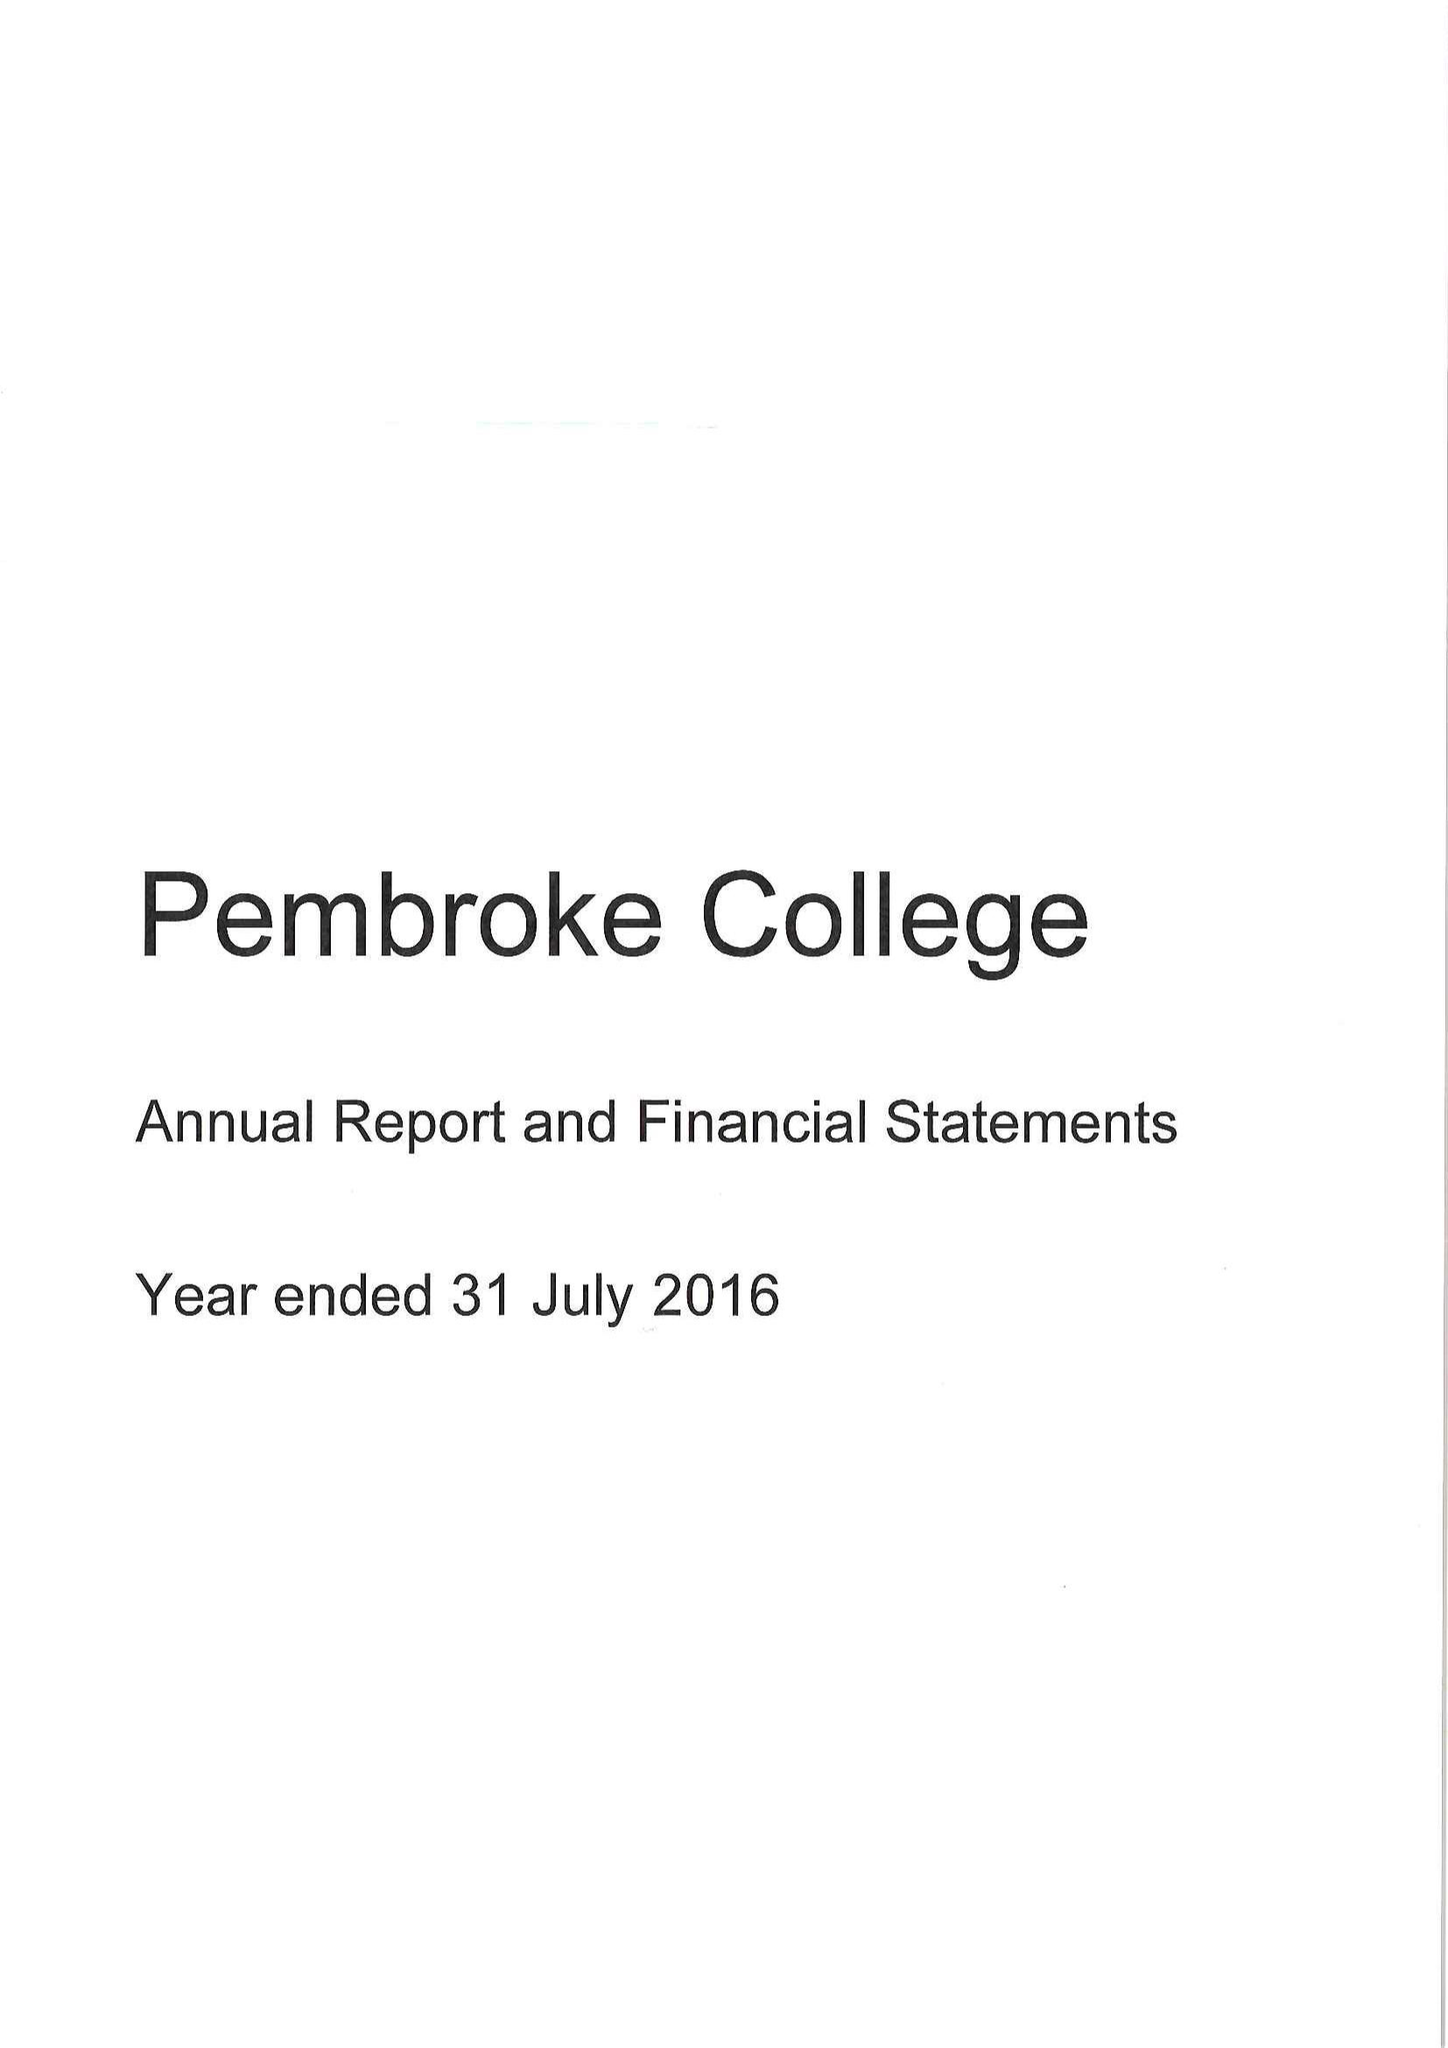What is the value for the spending_annually_in_british_pounds?
Answer the question using a single word or phrase. 11122000.00 